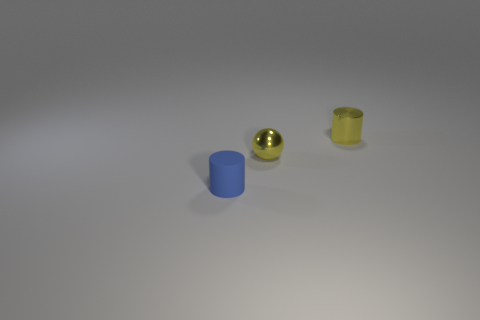What number of other tiny cylinders are the same material as the small blue cylinder?
Provide a succinct answer. 0. There is a cylinder left of the tiny metal thing that is behind the tiny yellow ball; what size is it?
Give a very brief answer. Small. What is the color of the object that is both in front of the small metal cylinder and behind the blue matte object?
Make the answer very short. Yellow. There is a shiny object that is the same color as the ball; what is its size?
Offer a terse response. Small. There is a yellow metallic object in front of the cylinder right of the blue rubber thing; what shape is it?
Your response must be concise. Sphere. Do the tiny blue thing and the small object behind the small metallic ball have the same shape?
Offer a very short reply. Yes. The metal cylinder that is the same size as the blue matte thing is what color?
Give a very brief answer. Yellow. Are there fewer yellow metal cylinders behind the yellow cylinder than yellow objects that are to the left of the small blue matte cylinder?
Provide a succinct answer. No. What shape is the yellow object in front of the tiny yellow thing behind the small metal thing to the left of the small yellow shiny cylinder?
Your answer should be compact. Sphere. There is a small cylinder that is behind the tiny sphere; is it the same color as the metal thing left of the small metallic cylinder?
Give a very brief answer. Yes. 